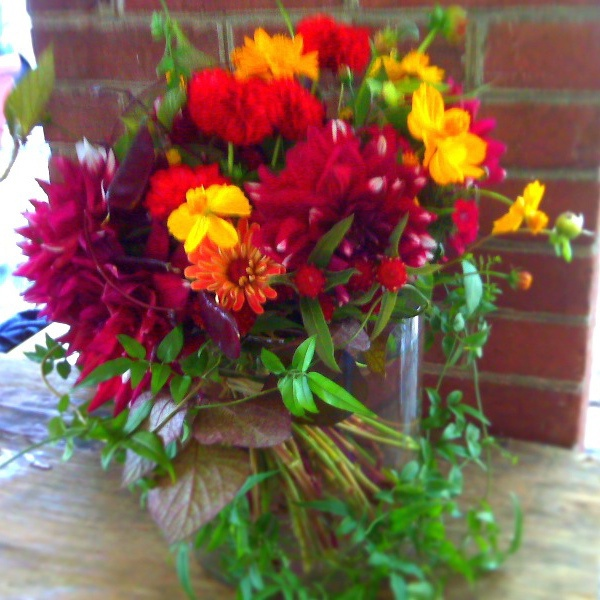Describe the objects in this image and their specific colors. I can see potted plant in white, maroon, darkgreen, brown, and black tones and vase in white, gray, darkgreen, maroon, and green tones in this image. 